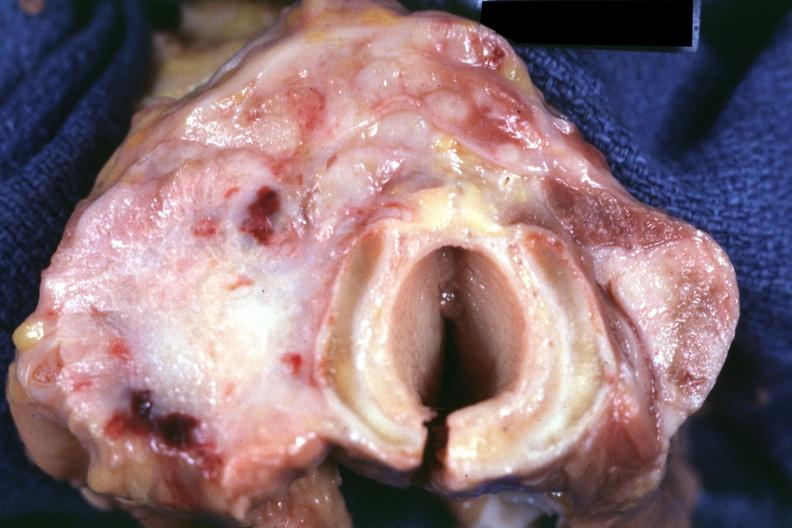what had colon carcinoma?
Answer the question using a single word or phrase. 70yof 